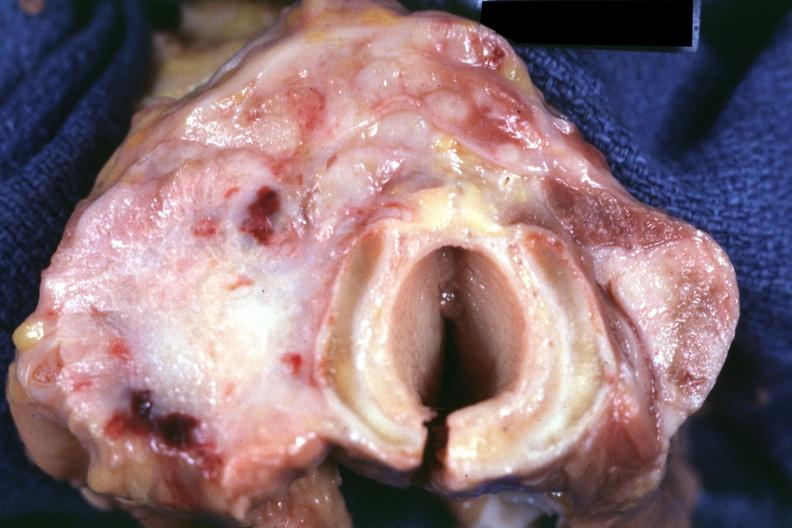what had colon carcinoma?
Answer the question using a single word or phrase. 70yof 